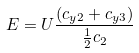Convert formula to latex. <formula><loc_0><loc_0><loc_500><loc_500>E = U \frac { ( c _ { y 2 } + c _ { y 3 } ) } { \frac { 1 } { 2 } c _ { 2 } }</formula> 